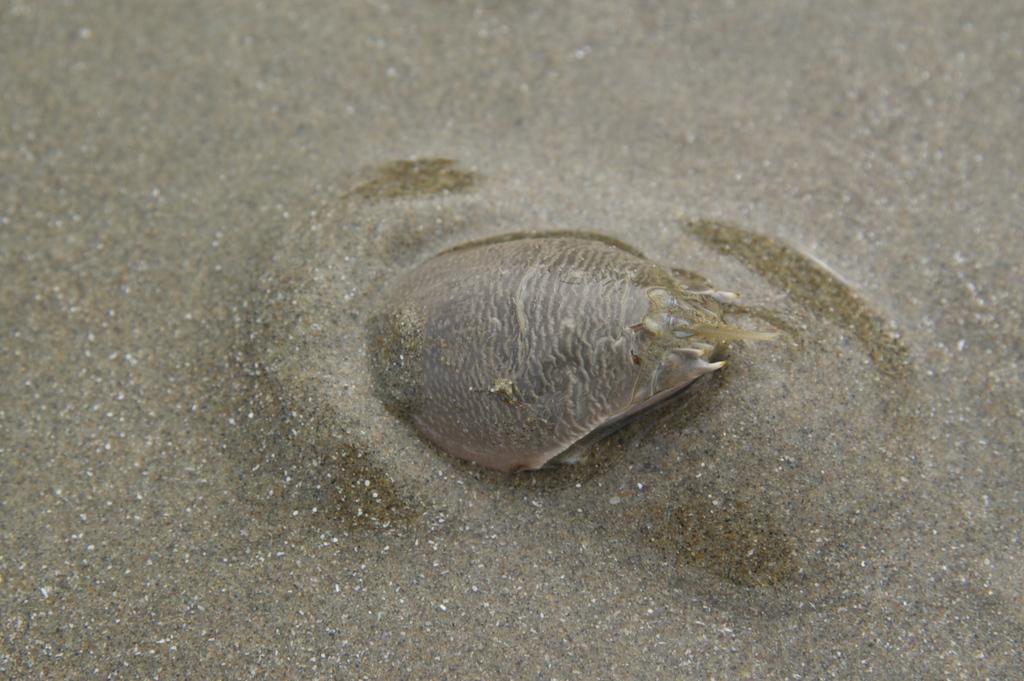Describe this image in one or two sentences. In the center of the image there is a sea animal in the water. 